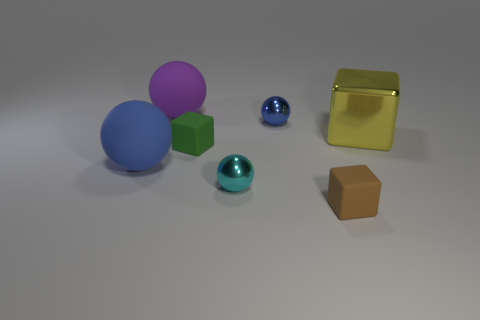How many objects are there in the image, and can you describe their colors? There are six objects in the image. Starting from the left, there's a large blue sphere, a medium-sized purple sphere, a small green cube, a tiny blue sphere, a gold-colored reflective cube, and a small brown cube. Which object stands out the most due to its size? The large blue sphere stands out the most due to its size; it's the largest object in the group. 